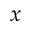<formula> <loc_0><loc_0><loc_500><loc_500>x</formula> 